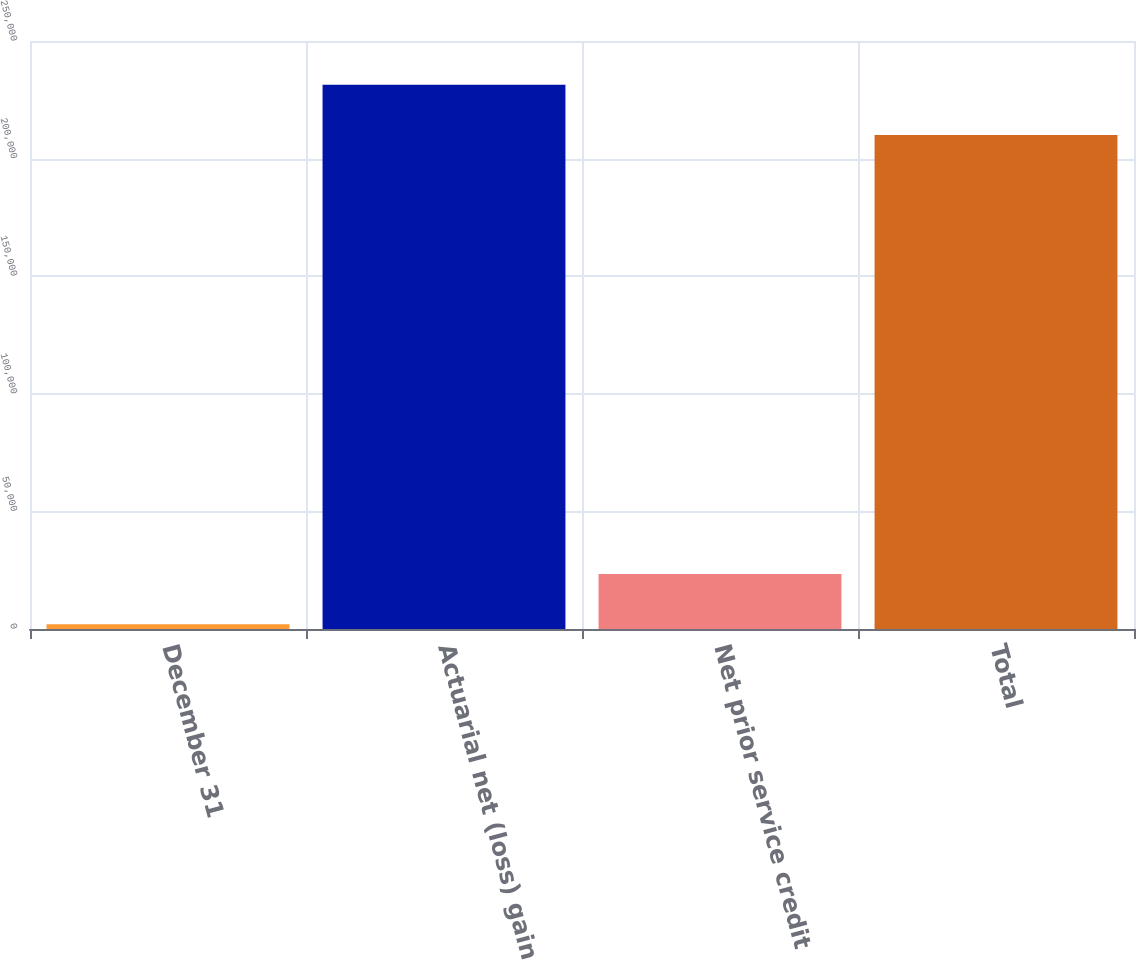<chart> <loc_0><loc_0><loc_500><loc_500><bar_chart><fcel>December 31<fcel>Actuarial net (loss) gain<fcel>Net prior service credit<fcel>Total<nl><fcel>2013<fcel>231373<fcel>23381.9<fcel>210004<nl></chart> 